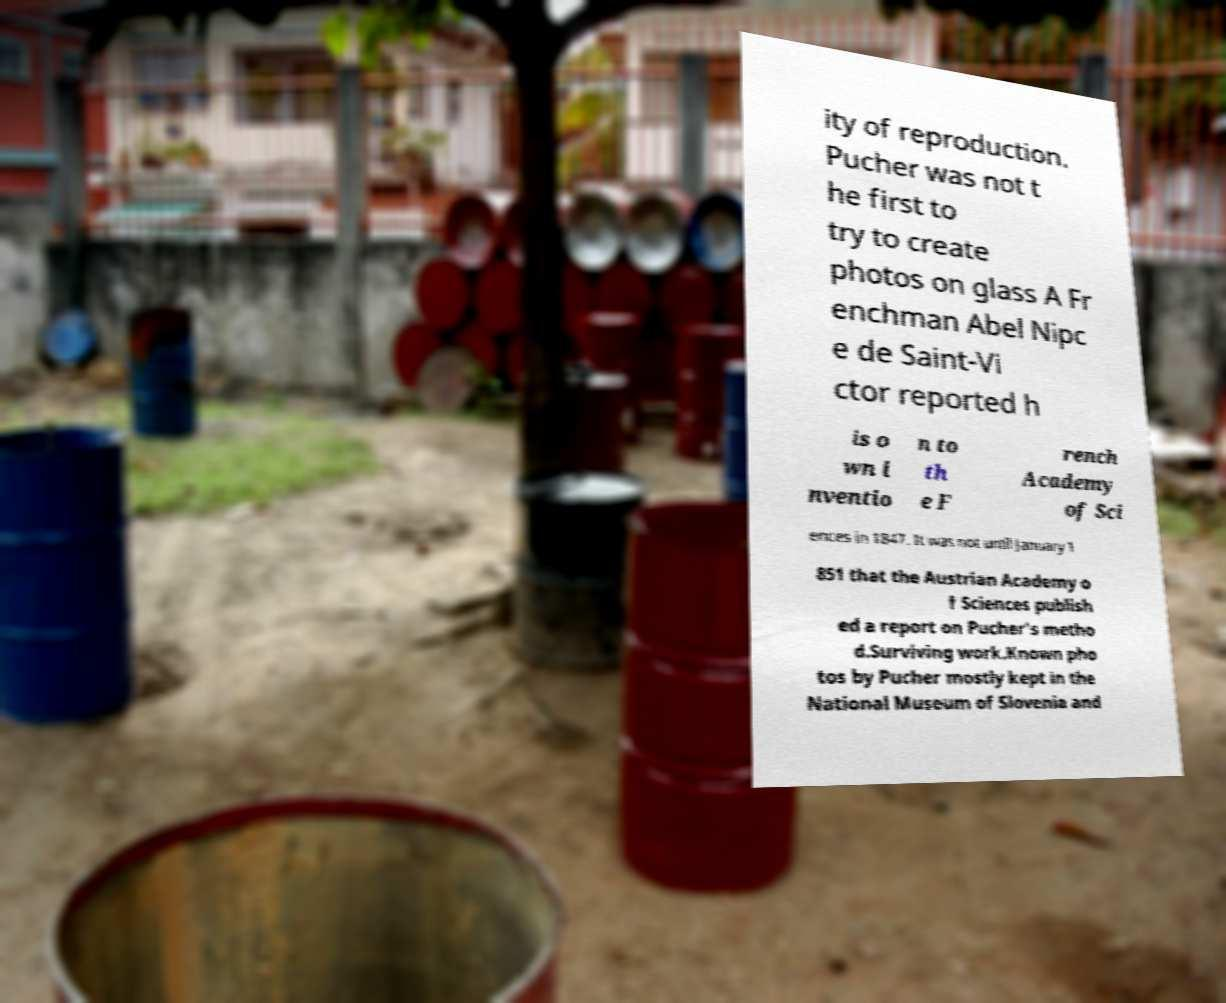Could you extract and type out the text from this image? ity of reproduction. Pucher was not t he first to try to create photos on glass A Fr enchman Abel Nipc e de Saint-Vi ctor reported h is o wn i nventio n to th e F rench Academy of Sci ences in 1847. It was not until January 1 851 that the Austrian Academy o f Sciences publish ed a report on Pucher's metho d.Surviving work.Known pho tos by Pucher mostly kept in the National Museum of Slovenia and 